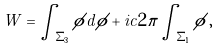<formula> <loc_0><loc_0><loc_500><loc_500>W = \int _ { \Sigma _ { 3 } } { \phi d \phi } + i c 2 \pi \int _ { \Sigma _ { 1 } } \phi \, ,</formula> 